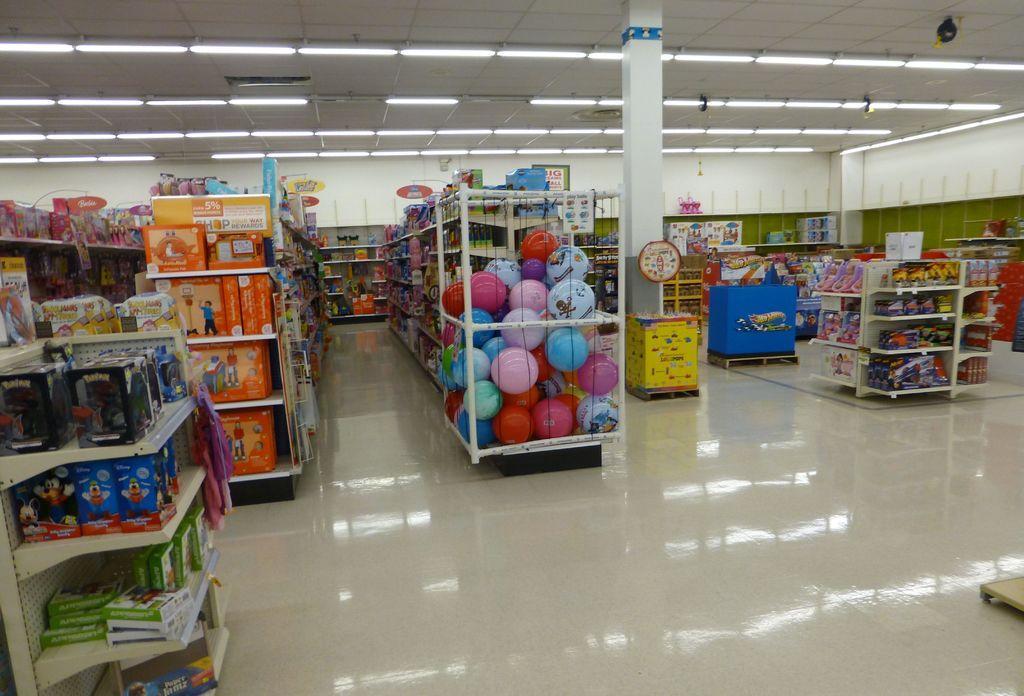Could you give a brief overview of what you see in this image? There are racks in the foreground area of the image, which contains different types of items, there is a pillar and lamps on the roof at the top side. 